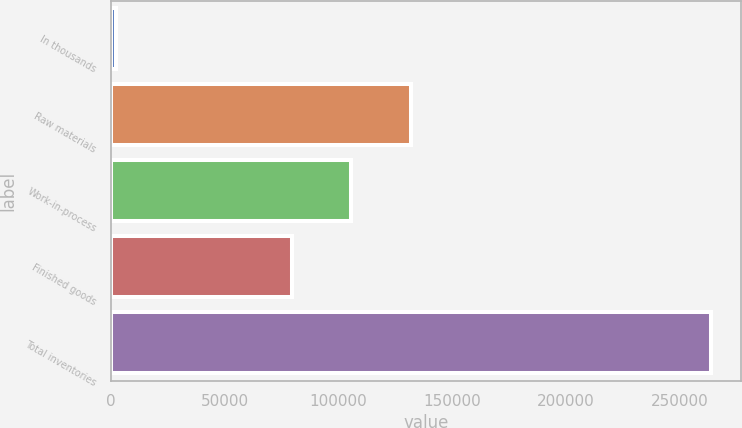Convert chart. <chart><loc_0><loc_0><loc_500><loc_500><bar_chart><fcel>In thousands<fcel>Raw materials<fcel>Work-in-process<fcel>Finished goods<fcel>Total inventories<nl><fcel>2008<fcel>131844<fcel>105629<fcel>79414<fcel>264158<nl></chart> 